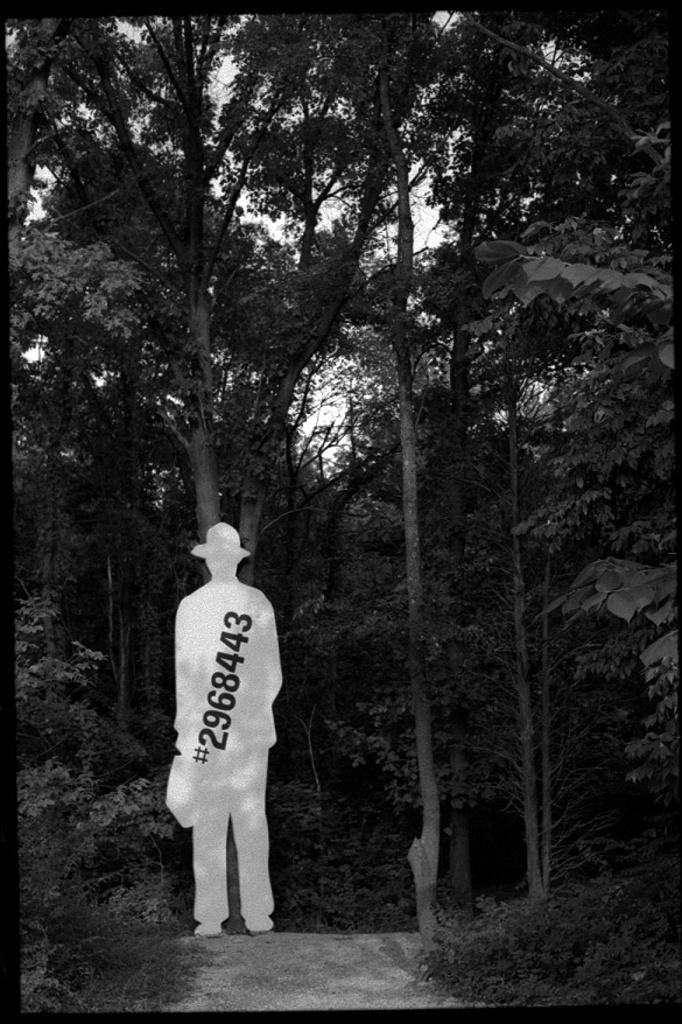What can be seen in the sky in the image? The sky is visible in the image. What type of natural elements are present in the image? There are trees in the image. Can you describe the object that resembles a person? The object has a number on it. What is located at the bottom of the image? There are plants at the bottom of the image. Are there any pets visible in the image? There is no mention of pets in the image; it only features the sky, trees, an object resembling a person, and plants. 